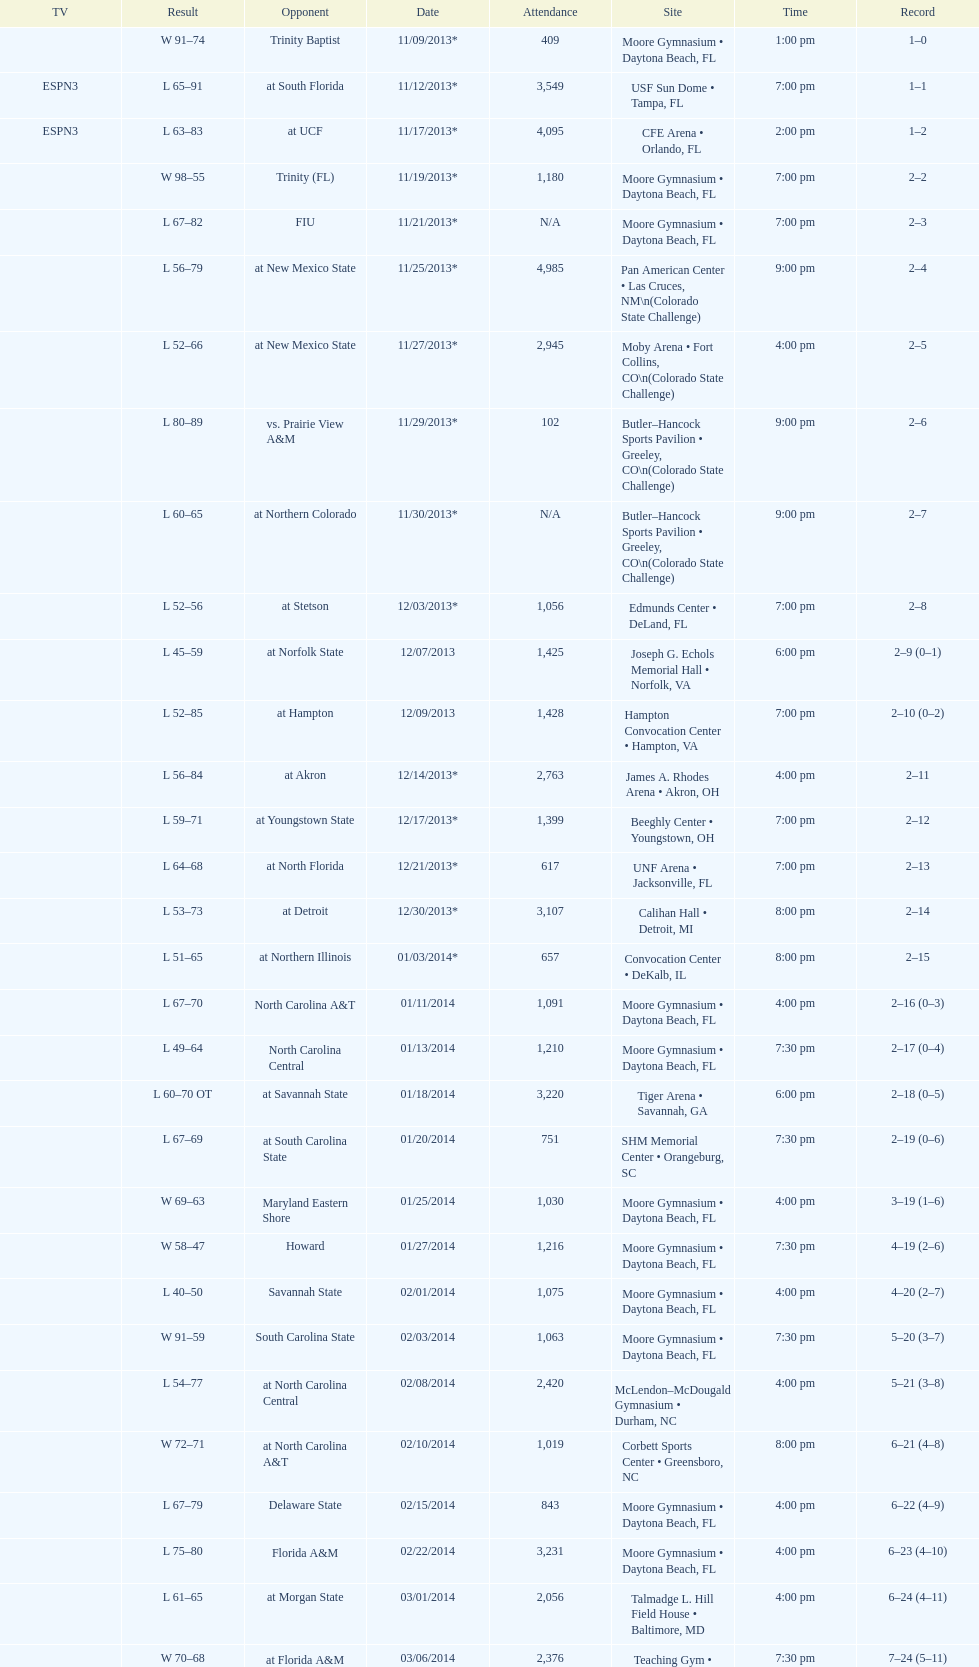How many games witnessed a crowd of more than 1,500 attendees? 12. 